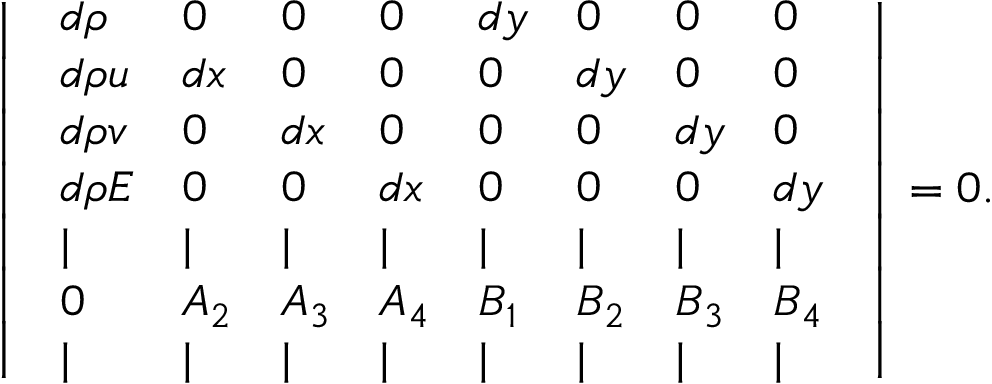<formula> <loc_0><loc_0><loc_500><loc_500>\left | \begin{array} { l l l l l l l l } { d \rho } & { 0 } & { 0 } & { 0 } & { d y } & { 0 } & { 0 } & { 0 } \\ { d \rho u } & { d x } & { 0 } & { 0 } & { 0 } & { d y } & { 0 } & { 0 } \\ { d \rho v } & { 0 } & { d x } & { 0 } & { 0 } & { 0 } & { d y } & { 0 } \\ { d \rho E } & { 0 } & { 0 } & { d x } & { 0 } & { 0 } & { 0 } & { d y } \\ { | } & { | } & { | } & { | } & { | } & { | } & { | } & { | } \\ { 0 } & { A _ { 2 } } & { A _ { 3 } } & { A _ { 4 } } & { B _ { 1 } } & { B _ { 2 } } & { B _ { 3 } } & { B _ { 4 } } \\ { | } & { | } & { | } & { | } & { | } & { | } & { | } & { | } \end{array} \right | = 0 .</formula> 